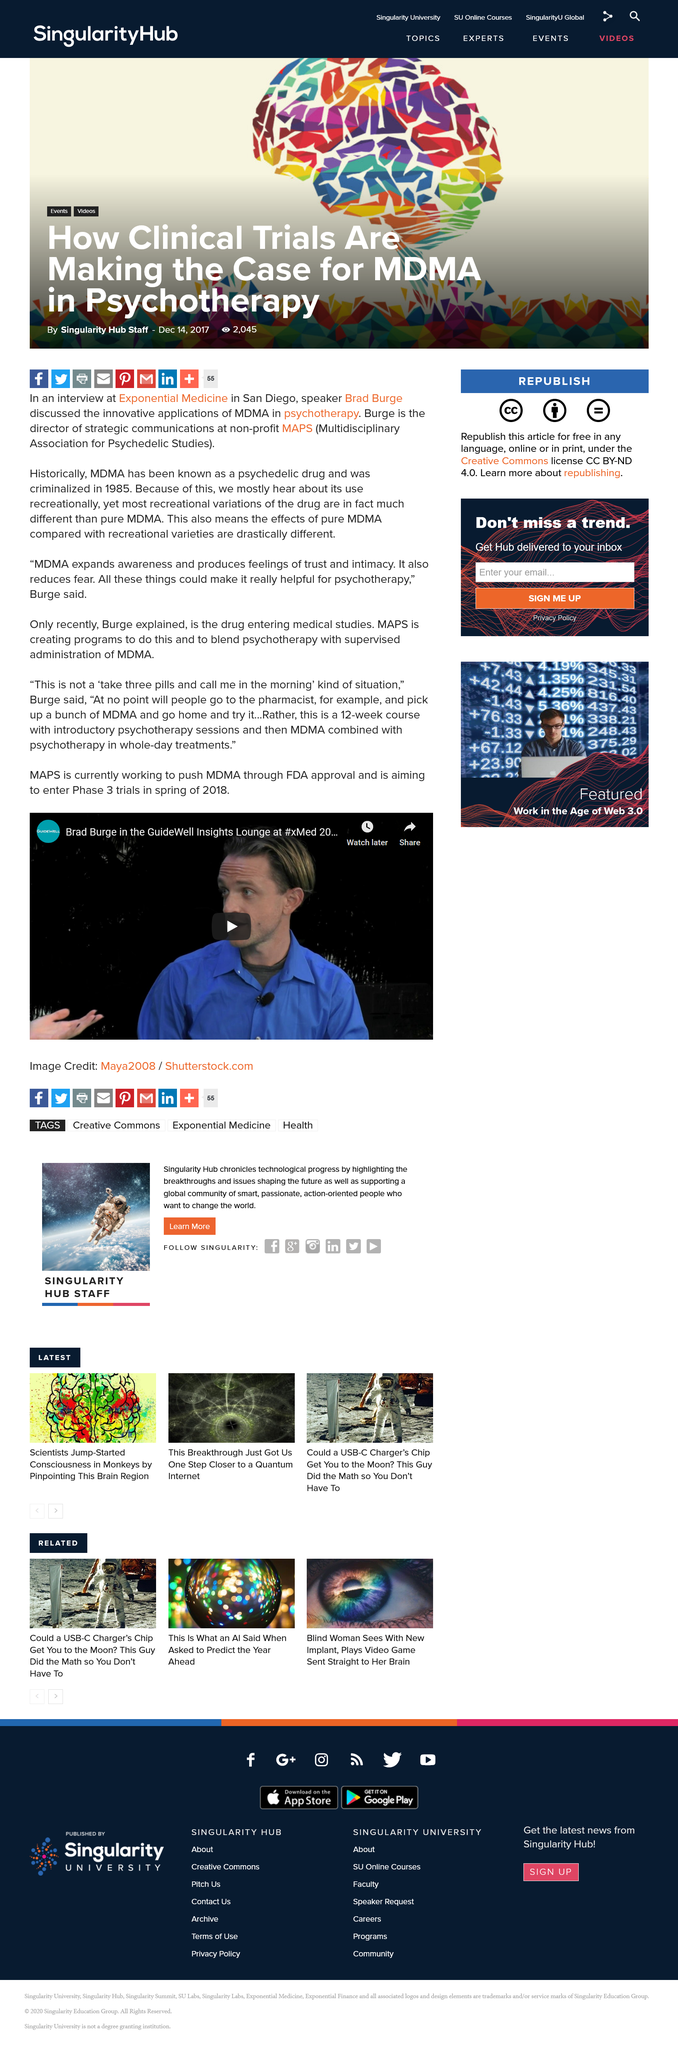Give some essential details in this illustration. The guest speaker on Guidewell is Brad Burge. The treatment course is 12 weeks in duration. MDMA is a drug that is commonly used in combination with psychotherapy treatment. 